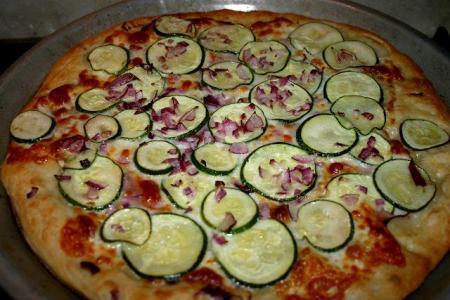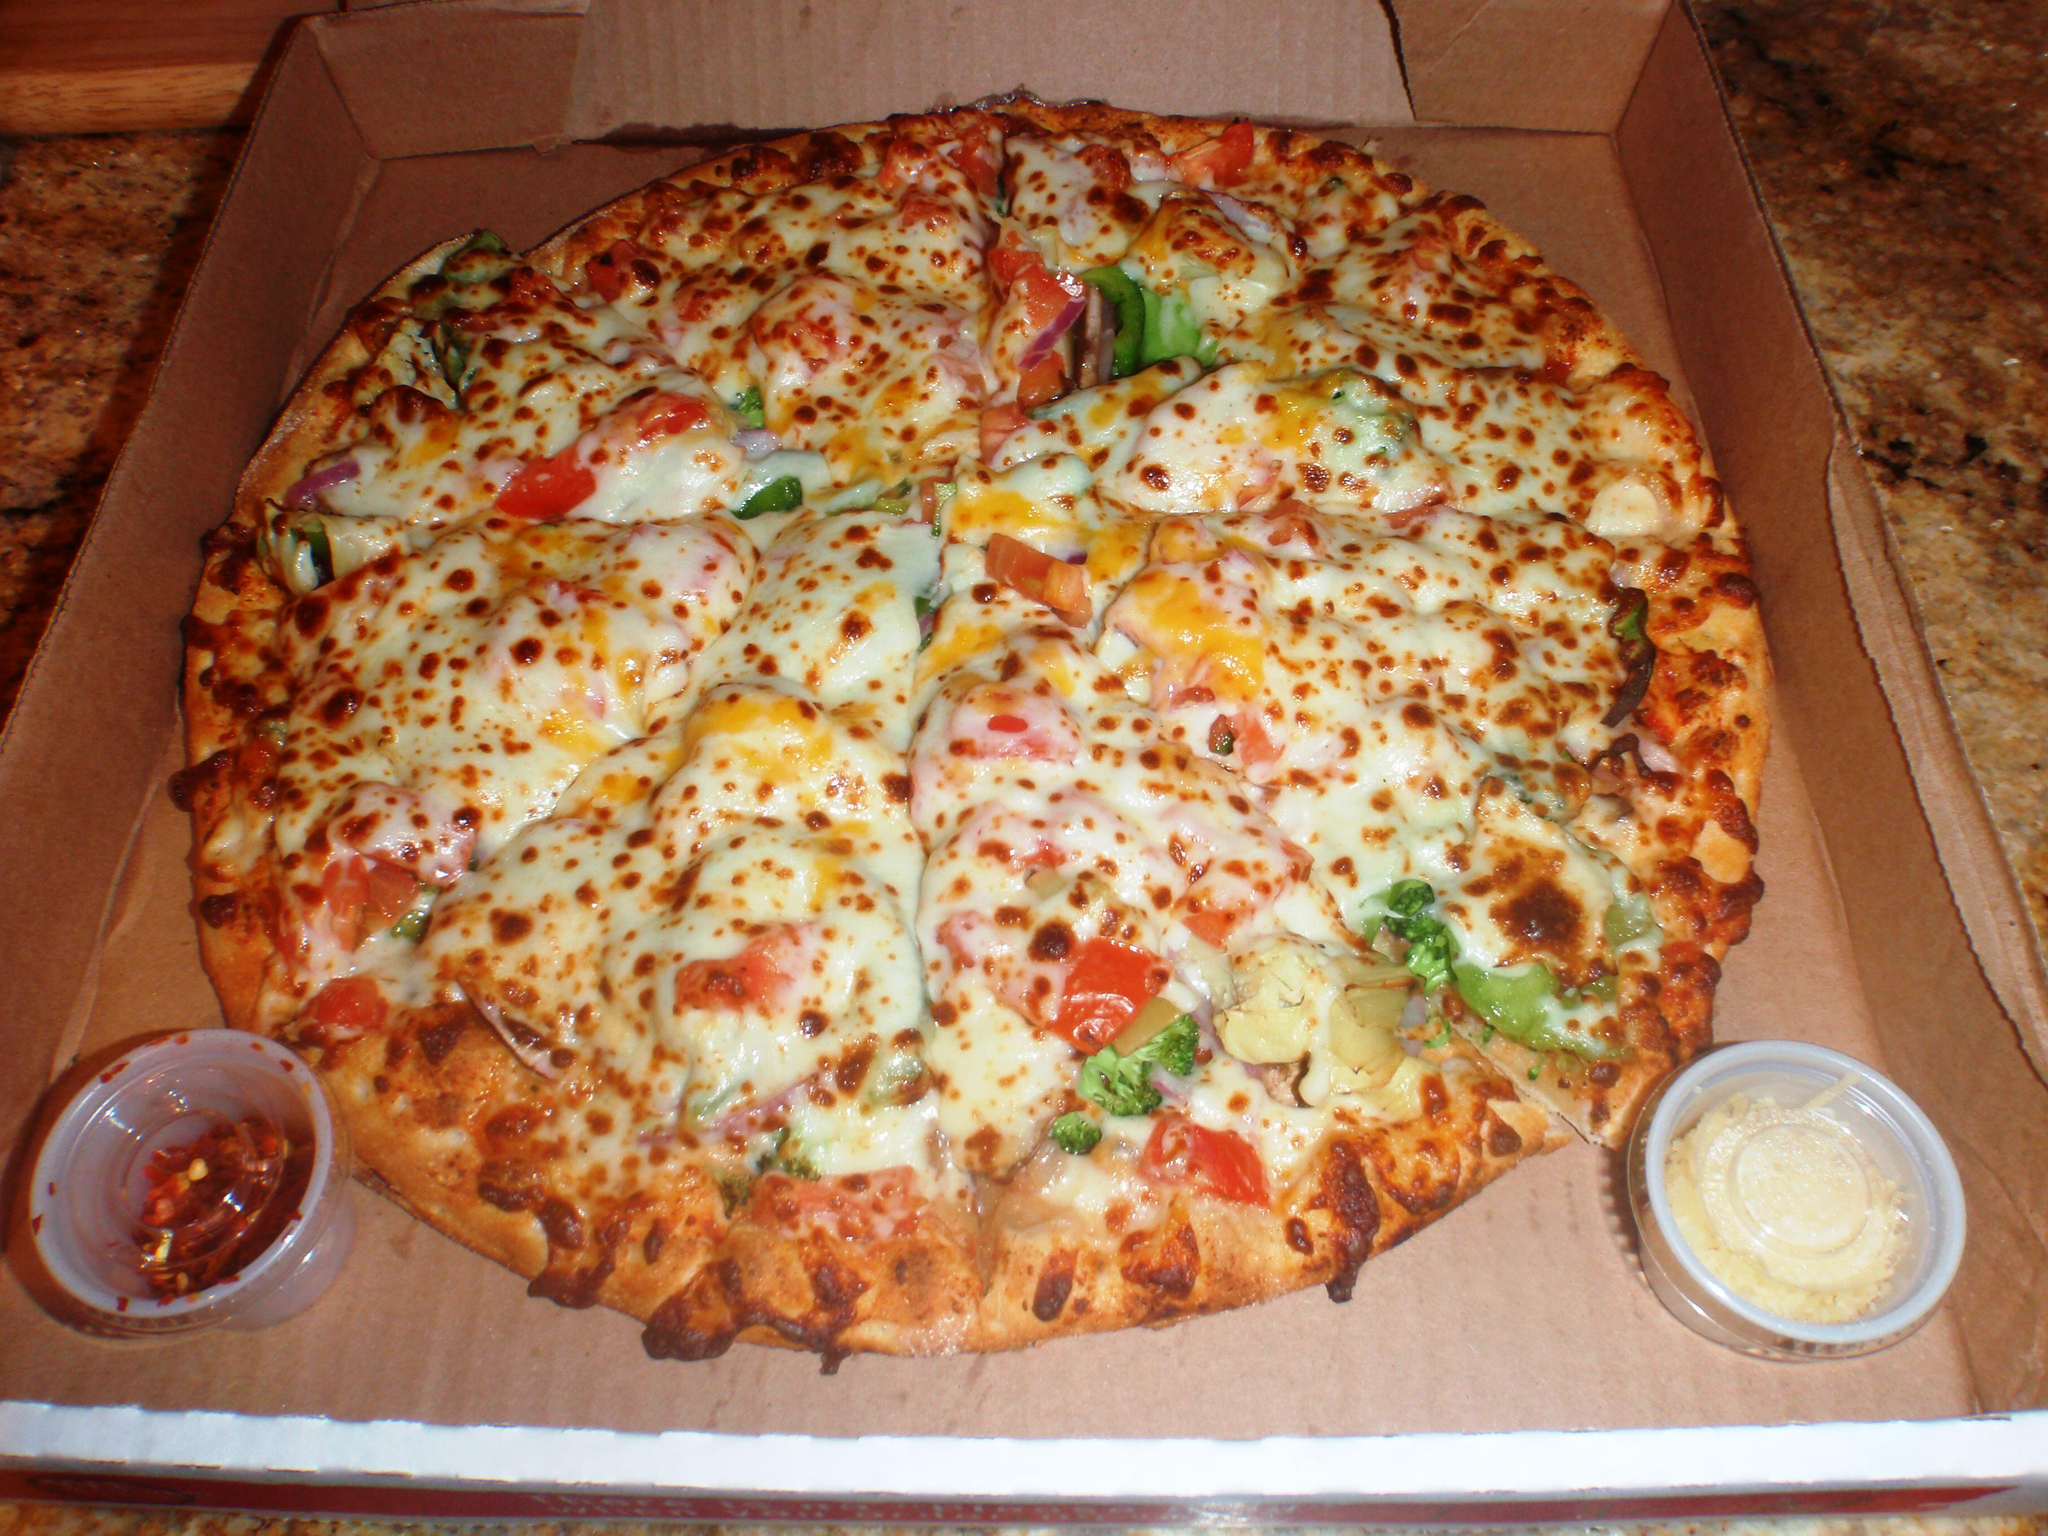The first image is the image on the left, the second image is the image on the right. Examine the images to the left and right. Is the description "The left and right image contains the same number of circle shaped pizzas." accurate? Answer yes or no. Yes. The first image is the image on the left, the second image is the image on the right. Analyze the images presented: Is the assertion "At least one pizza has a slice cut out of it." valid? Answer yes or no. No. 